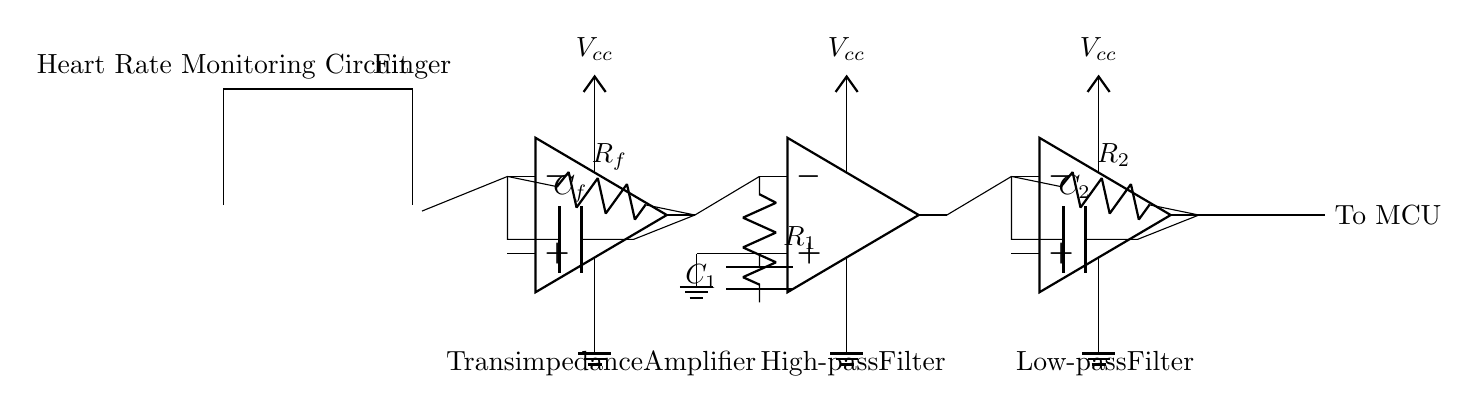What is the main purpose of this circuit? The main purpose of this circuit is to monitor heart rate by measuring the pulse using photoplethysmography. This is achieved by detecting changes in light absorption in the finger, which corresponds to the heartbeat.
Answer: Heart rate monitoring What component emits light in this circuit? The component that emits light is the infrared LED, which sends out infrared light to detect changes in blood volume through the finger.
Answer: Infrared LED How many operational amplifiers are used in this circuit? There are three operational amplifiers used in this circuit, which are part of the transimpedance amplifier and filtering stages.
Answer: Three What does the photodiode detect? The photodiode detects the changes in light intensity reflected back from the finger, allowing it to measure the blood volume changes due to the heartbeat.
Answer: Light intensity What type of filter is used after the transimpedance amplifier? A high-pass filter is used after the transimpedance amplifier to eliminate low-frequency noise and allow the heart rate signal to pass through.
Answer: High-pass filter Why is a low-pass filter included in this circuit? The low-pass filter is included to remove high-frequency noise from the heart rate signal, ensuring a clearer reading of the pulse. This helps in improving the accuracy of the heart rate measurement.
Answer: To remove high-frequency noise What is the role of the capacitor labeled C1 in the circuit? The capacitor labeled C1, in conjunction with the resistor R1, forms the high-pass filter that allows the pulsating heart rate signal to pass while blocking lower frequencies, enhancing the signal quality for further processing.
Answer: High-pass filter function 